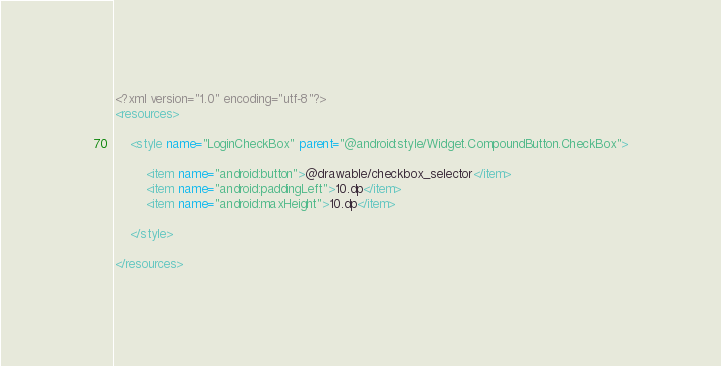Convert code to text. <code><loc_0><loc_0><loc_500><loc_500><_XML_><?xml version="1.0" encoding="utf-8"?>
<resources>

    <style name="LoginCheckBox" parent="@android:style/Widget.CompoundButton.CheckBox">

        <item name="android:button">@drawable/checkbox_selector</item>
        <item name="android:paddingLeft">10.dp</item>
        <item name="android:maxHeight">10.dp</item>

    </style>

</resources></code> 